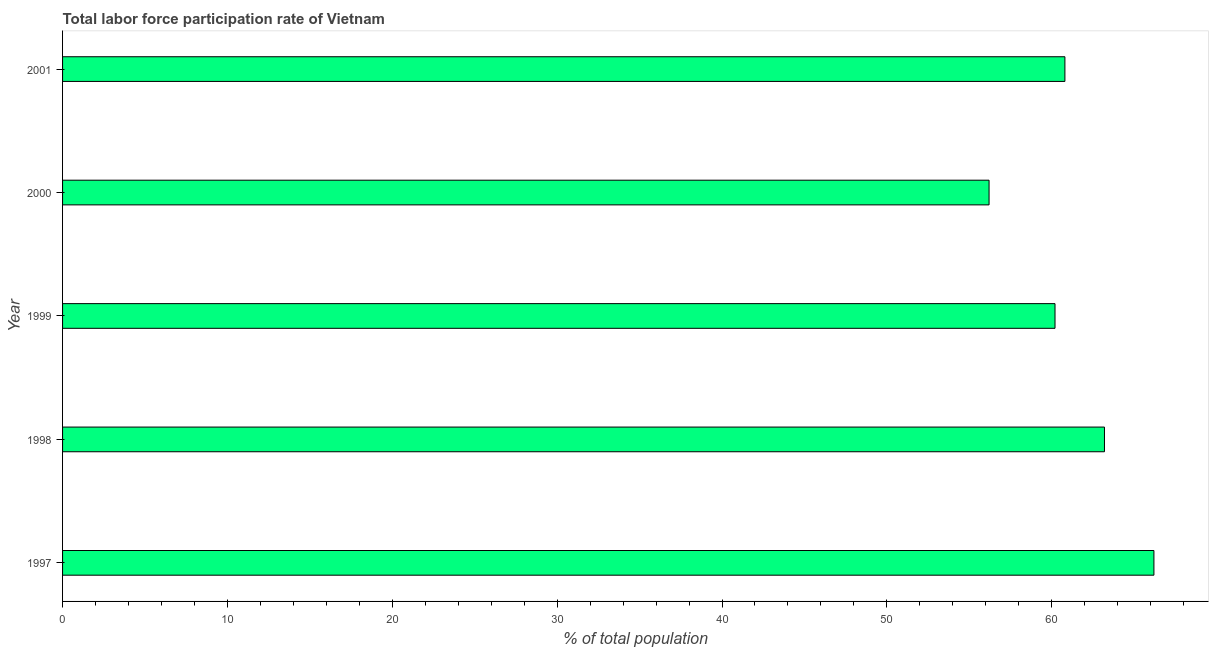Does the graph contain grids?
Make the answer very short. No. What is the title of the graph?
Your response must be concise. Total labor force participation rate of Vietnam. What is the label or title of the X-axis?
Offer a very short reply. % of total population. What is the label or title of the Y-axis?
Keep it short and to the point. Year. What is the total labor force participation rate in 2001?
Give a very brief answer. 60.8. Across all years, what is the maximum total labor force participation rate?
Ensure brevity in your answer.  66.2. Across all years, what is the minimum total labor force participation rate?
Make the answer very short. 56.2. In which year was the total labor force participation rate maximum?
Your answer should be compact. 1997. In which year was the total labor force participation rate minimum?
Make the answer very short. 2000. What is the sum of the total labor force participation rate?
Offer a very short reply. 306.6. What is the difference between the total labor force participation rate in 1998 and 2000?
Ensure brevity in your answer.  7. What is the average total labor force participation rate per year?
Provide a short and direct response. 61.32. What is the median total labor force participation rate?
Your answer should be very brief. 60.8. Do a majority of the years between 1999 and 1998 (inclusive) have total labor force participation rate greater than 48 %?
Your answer should be very brief. No. What is the ratio of the total labor force participation rate in 1997 to that in 2001?
Offer a very short reply. 1.09. Is the total labor force participation rate in 1999 less than that in 2000?
Give a very brief answer. No. Is the difference between the total labor force participation rate in 1998 and 2000 greater than the difference between any two years?
Your answer should be compact. No. How many bars are there?
Provide a short and direct response. 5. Are the values on the major ticks of X-axis written in scientific E-notation?
Offer a terse response. No. What is the % of total population in 1997?
Keep it short and to the point. 66.2. What is the % of total population in 1998?
Your response must be concise. 63.2. What is the % of total population of 1999?
Give a very brief answer. 60.2. What is the % of total population of 2000?
Keep it short and to the point. 56.2. What is the % of total population of 2001?
Provide a succinct answer. 60.8. What is the difference between the % of total population in 1997 and 1998?
Your answer should be very brief. 3. What is the difference between the % of total population in 1997 and 1999?
Give a very brief answer. 6. What is the difference between the % of total population in 1998 and 2000?
Give a very brief answer. 7. What is the difference between the % of total population in 1998 and 2001?
Provide a short and direct response. 2.4. What is the ratio of the % of total population in 1997 to that in 1998?
Make the answer very short. 1.05. What is the ratio of the % of total population in 1997 to that in 1999?
Provide a short and direct response. 1.1. What is the ratio of the % of total population in 1997 to that in 2000?
Keep it short and to the point. 1.18. What is the ratio of the % of total population in 1997 to that in 2001?
Provide a succinct answer. 1.09. What is the ratio of the % of total population in 1998 to that in 2001?
Your answer should be compact. 1.04. What is the ratio of the % of total population in 1999 to that in 2000?
Make the answer very short. 1.07. What is the ratio of the % of total population in 2000 to that in 2001?
Make the answer very short. 0.92. 